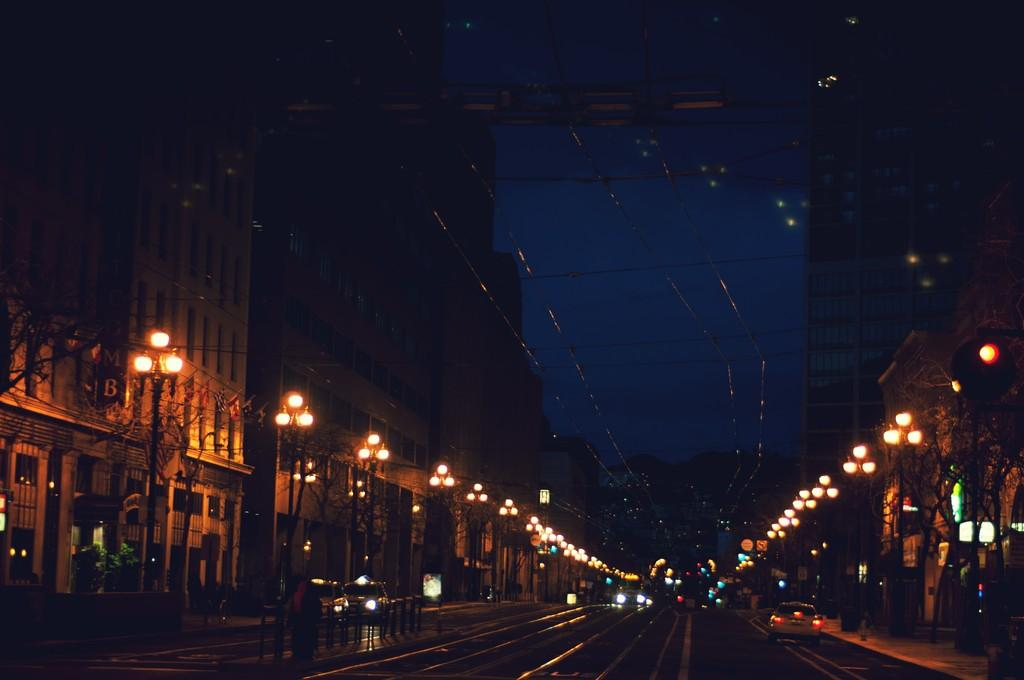What can be seen moving on the road in the image? There are vehicles on the road in the image. What structures are present alongside the road? There are poles, lights, trees, and buildings on either side of the road. How many types of structures are present alongside the road? There are four types of structures present alongside the road: poles, lights, trees, and buildings. Can you see any cracks on the road in the image? There is no mention of cracks on the road in the provided facts, so we cannot determine if any are present in the image. Is there a battle taking place on the road in the image? There is no indication of a battle or any conflict in the image, as it features vehicles on the road and structures alongside it. 